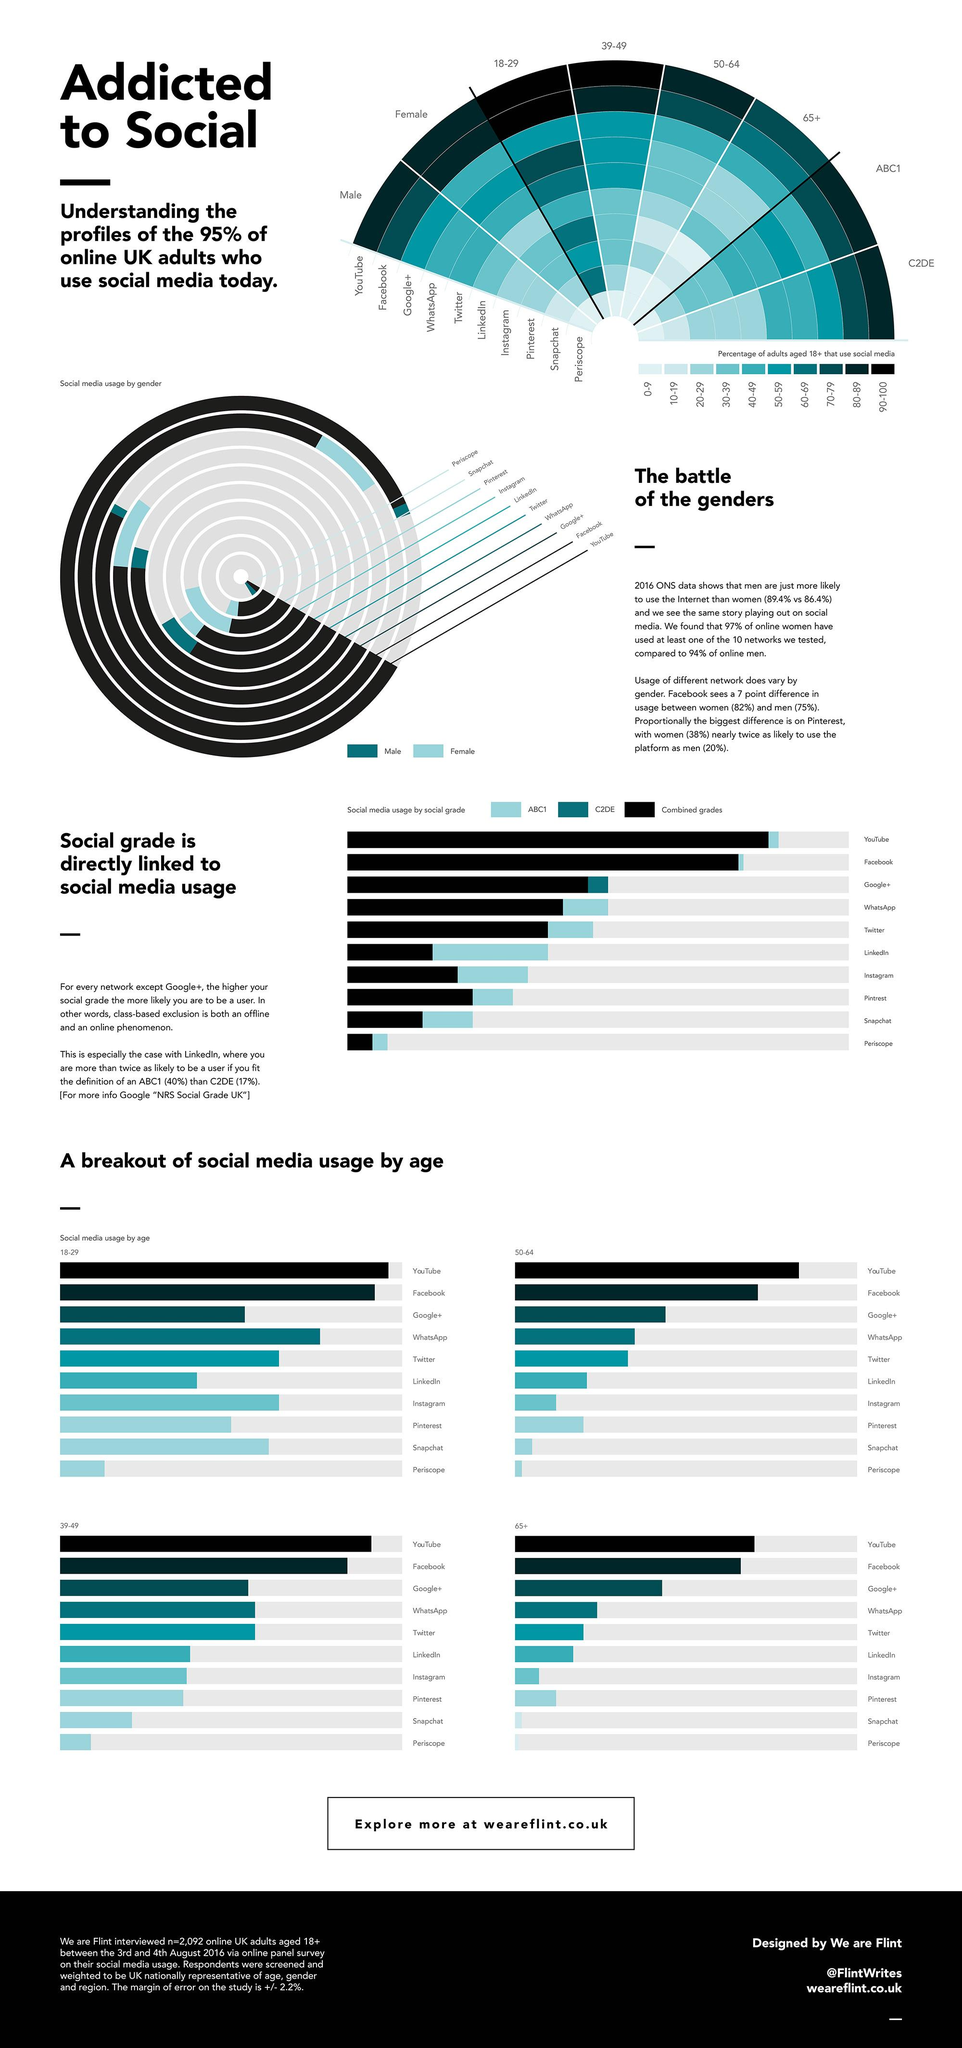List a handful of essential elements in this visual. According to data, Google+ is the third most popular social media platform among 50-64 year olds. It is widely known that Facebook is the second most popular social media platform among 50-64 year olds. According to statistics, a significant percentage of 65+ year old people use YouTube, with those in the 70-79 age range being the highest users. The use of Twitter is more prevalent among males rather than females. According to research, Facebook is more popular among people in the ABC1 social grade. 